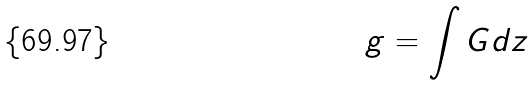<formula> <loc_0><loc_0><loc_500><loc_500>g = \int G d z</formula> 